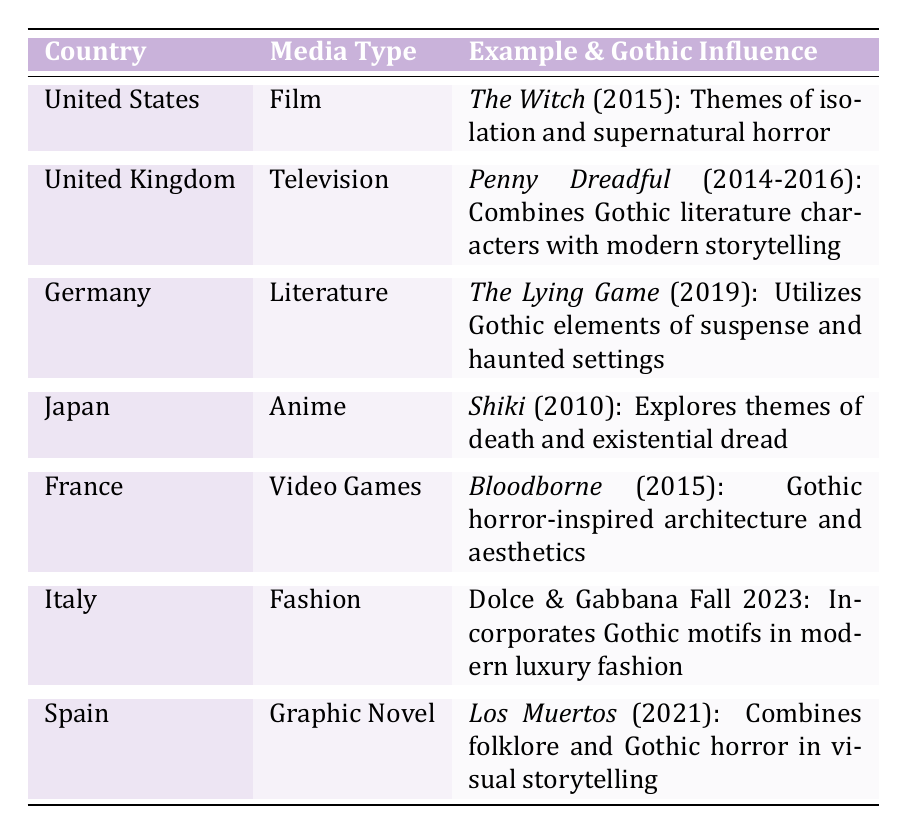What country is associated with the media type "Film"? Referring to the table, the country that fits the criteria of being associated with the media type "Film" is the United States, which lists "The Witch (2015)" as an example.
Answer: United States Which media type features a Gothic influence related to "Penny Dreadful"? The table indicates that "Penny Dreadful" is a television series from the United Kingdom. Thus, the media type associated is "Television."
Answer: Television What is the notable award received by "Bloodborne"? According to the table, "Bloodborne" (2015) won the "Game Awards - Best Art Direction."
Answer: Game Awards - Best Art Direction How many different countries are represented in the table? By counting each country entry in the table, we find there are seven distinct countries listed.
Answer: 7 Does Germany's example utilize Gothic elements in its narrative? The table states that "The Lying Game" in Germany utilizes Gothic elements, confirming this as true.
Answer: Yes Which example combines folklore and Gothic horror? The table shows that "Los Muertos" (2021) from Spain combines folklore with Gothic horror.
Answer: Los Muertos Compare the media types for Japan and Italy. Are they different? Japan features "Anime," while Italy lists "Fashion." Since these two terms refer to different categories, they are different.
Answer: Yes What influence is noted in the example from the United States? The influence noted for "The Witch" (2015) in the United States is the themes of isolation and supernatural horror.
Answer: Themes of isolation and supernatural horror Aggregate the number of unique media types in the table. The media types listed are Film, Television, Literature, Anime, Video Games, Fashion, and Graphic Novel. Counting these results in a total of seven unique media types.
Answer: 7 Which country has a fashion example incorporating Gothic motifs, and what is the collection? Italy has the Dolce & Gabbana Fall 2023 Collection, which incorporates Gothic motifs.
Answer: Italy, Dolce & Gabbana Fall 2023 Collection What common theme in Gothic influences can be observed in contemporary media? A common theme across various examples, such as isolation, suspense, and existential dread, showcases how Gothic elements persist in contemporary media.
Answer: Isolation, suspense, existential dread 